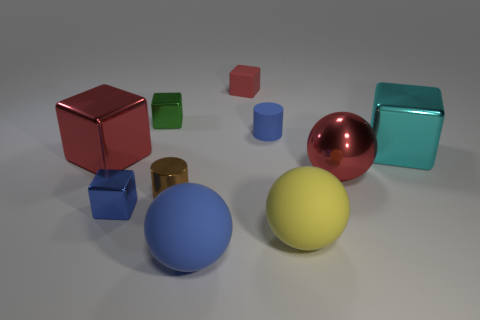How many red objects are rubber cylinders or metal cubes?
Give a very brief answer. 1. Do the tiny cylinder that is right of the tiny red block and the large yellow thing have the same material?
Your response must be concise. Yes. What number of other objects are the same material as the large red block?
Offer a terse response. 5. What material is the brown object?
Offer a very short reply. Metal. There is a blue object left of the green block; what is its size?
Provide a succinct answer. Small. There is a large object that is on the left side of the green shiny block; what number of large red metallic things are behind it?
Your answer should be very brief. 0. There is a big red metal thing that is to the right of the big blue rubber thing; is its shape the same as the red metal thing that is left of the large blue thing?
Give a very brief answer. No. How many cubes are both on the left side of the blue shiny object and in front of the brown object?
Offer a very short reply. 0. Is there a sphere that has the same color as the metal cylinder?
Provide a succinct answer. No. What is the shape of the brown shiny object that is the same size as the green metal object?
Offer a terse response. Cylinder. 